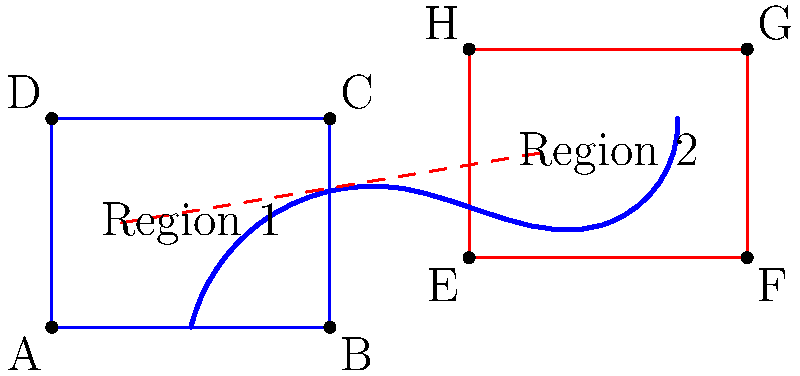In the strategic map above, two key regions are separated by a river. A supply route from Region 1 to Region 2 is proposed, crossing the river. If the river acts as a line of reflection for the supply route, what are the coordinates of the reflection of point $(1, 1.5)$ in Region 1 to its corresponding point in Region 2? To solve this problem, we need to follow these steps:

1) First, we need to determine the equation of the line representing the river. From the diagram, we can approximate it as a straight line for simplification. Let's say it passes through points $(5, 0)$ and $(5, 4)$.

2) The equation of this line would be $x = 5$.

3) For a reflection across a vertical line $x = a$, the transformation is:
   $(x, y) \rightarrow (2a - x, y)$

4) In our case, $a = 5$, and the point to be reflected is $(1, 1.5)$.

5) Applying the transformation:
   $x' = 2(5) - 1 = 9$
   $y' = 1.5$ (y-coordinate remains unchanged in a reflection across a vertical line)

6) Therefore, the reflected point is $(9, 1.5)$.
Answer: $(9, 1.5)$ 